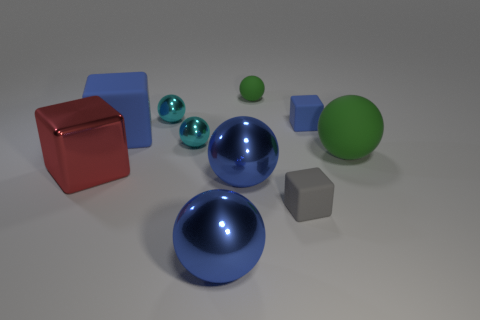There is another small object that is the same shape as the gray matte object; what is its color?
Provide a succinct answer. Blue. Are there any rubber blocks that are to the right of the tiny blue block that is behind the tiny gray thing?
Give a very brief answer. No. The red metal cube is what size?
Your answer should be very brief. Large. The blue object that is behind the large green object and on the left side of the gray object has what shape?
Your answer should be very brief. Cube. What number of yellow objects are tiny rubber things or tiny metal things?
Keep it short and to the point. 0. Does the green ball that is in front of the tiny blue rubber thing have the same size as the matte cube in front of the red metallic cube?
Your answer should be very brief. No. What number of things are either cyan cylinders or small blue rubber things?
Ensure brevity in your answer.  1. Is there a yellow metal object of the same shape as the gray matte thing?
Keep it short and to the point. No. Is the number of cyan shiny spheres less than the number of small rubber balls?
Your answer should be compact. No. Do the red shiny object and the small blue object have the same shape?
Provide a succinct answer. Yes. 